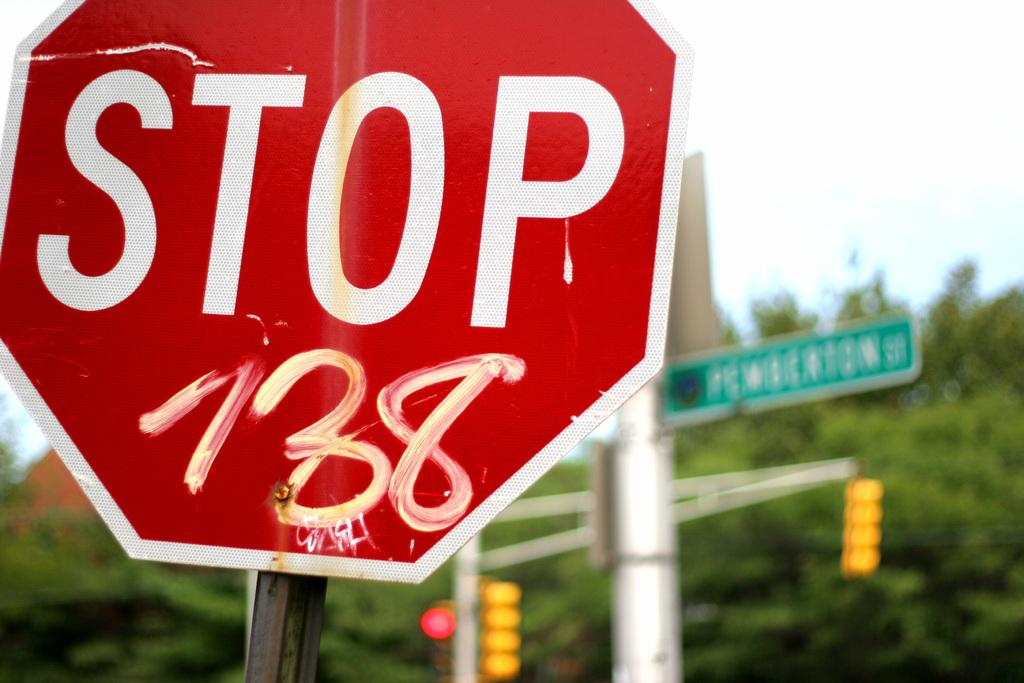<image>
Relay a brief, clear account of the picture shown. A STOP sign has white paint on it with that says 738. 